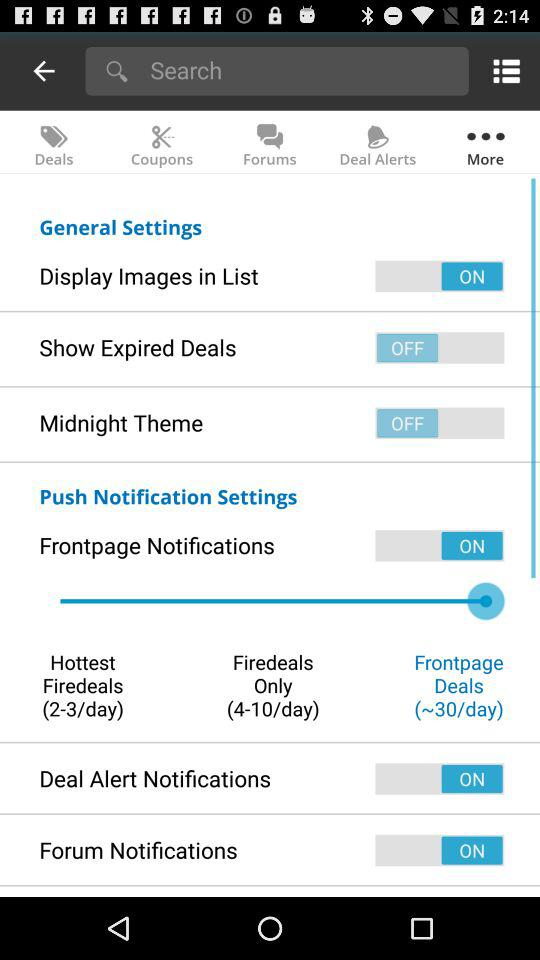Which tab is selected? The selected tab is "More". 